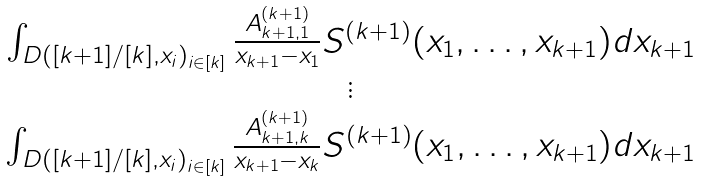<formula> <loc_0><loc_0><loc_500><loc_500>\begin{matrix} \int _ { D ( [ k + 1 ] / [ k ] , x _ { i } ) _ { i \in [ k ] } } \frac { A ^ { ( k + 1 ) } _ { k + 1 , 1 } } { x _ { k + 1 } - x _ { 1 } } S ^ { ( k + 1 ) } ( x _ { 1 } , \dots , x _ { k + 1 } ) d x _ { k + 1 } \\ \vdots \\ \int _ { D ( [ k + 1 ] / [ k ] , x _ { i } ) _ { i \in [ k ] } } \frac { A ^ { ( k + 1 ) } _ { k + 1 , k } } { x _ { k + 1 } - x _ { k } } S ^ { ( k + 1 ) } ( x _ { 1 } , \dots , x _ { k + 1 } ) d x _ { k + 1 } \\ \end{matrix}</formula> 